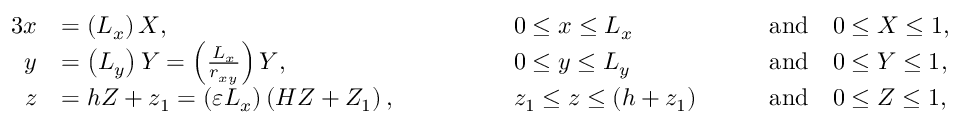<formula> <loc_0><loc_0><loc_500><loc_500>\begin{array} { r l r l r l } { { 3 } x } & { = \left ( L _ { x } \right ) X , \quad } & & { 0 \leq x \leq L _ { x } \quad } & & { a n d \quad 0 \leq X \leq 1 , } \\ { y } & { = \left ( L _ { y } \right ) Y = \left ( \frac { L _ { x } } { r _ { x y } } \right ) Y , \quad } & & { 0 \leq y \leq L _ { y } \quad } & & { a n d \quad 0 \leq Y \leq 1 , } \\ { z } & { = h Z + z _ { 1 } = \left ( \varepsilon L _ { x } \right ) \left ( H Z + Z _ { 1 } \right ) , \quad } & & { z _ { 1 } \leq z \leq \left ( h + z _ { 1 } \right ) \quad } & & { a n d \quad 0 \leq Z \leq 1 , } \end{array}</formula> 